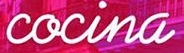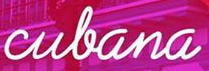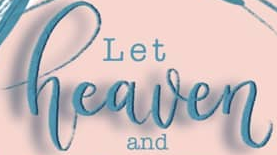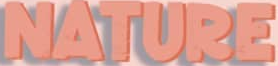What text appears in these images from left to right, separated by a semicolon? cocina; culana; heaven; NATURE 